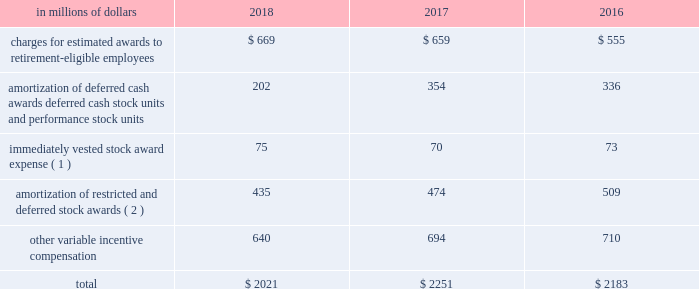Incentive compensation cost the table shows components of compensation expense , relating to certain of the incentive compensation programs described above : in a0millions a0of a0dollars 2018 2017 2016 charges for estimated awards to retirement-eligible employees $ 669 $ 659 $ 555 amortization of deferred cash awards , deferred cash stock units and performance stock units 202 354 336 immediately vested stock award expense ( 1 ) 75 70 73 amortization of restricted and deferred stock awards ( 2 ) 435 474 509 .
( 1 ) represents expense for immediately vested stock awards that generally were stock payments in lieu of cash compensation .
The expense is generally accrued as cash incentive compensation in the year prior to grant .
( 2 ) all periods include amortization expense for all unvested awards to non-retirement-eligible employees. .
What percentage of total compensation expense in 2017 is composed of other variable incentive compensation? 
Computations: (694 / 2251)
Answer: 0.30831. 